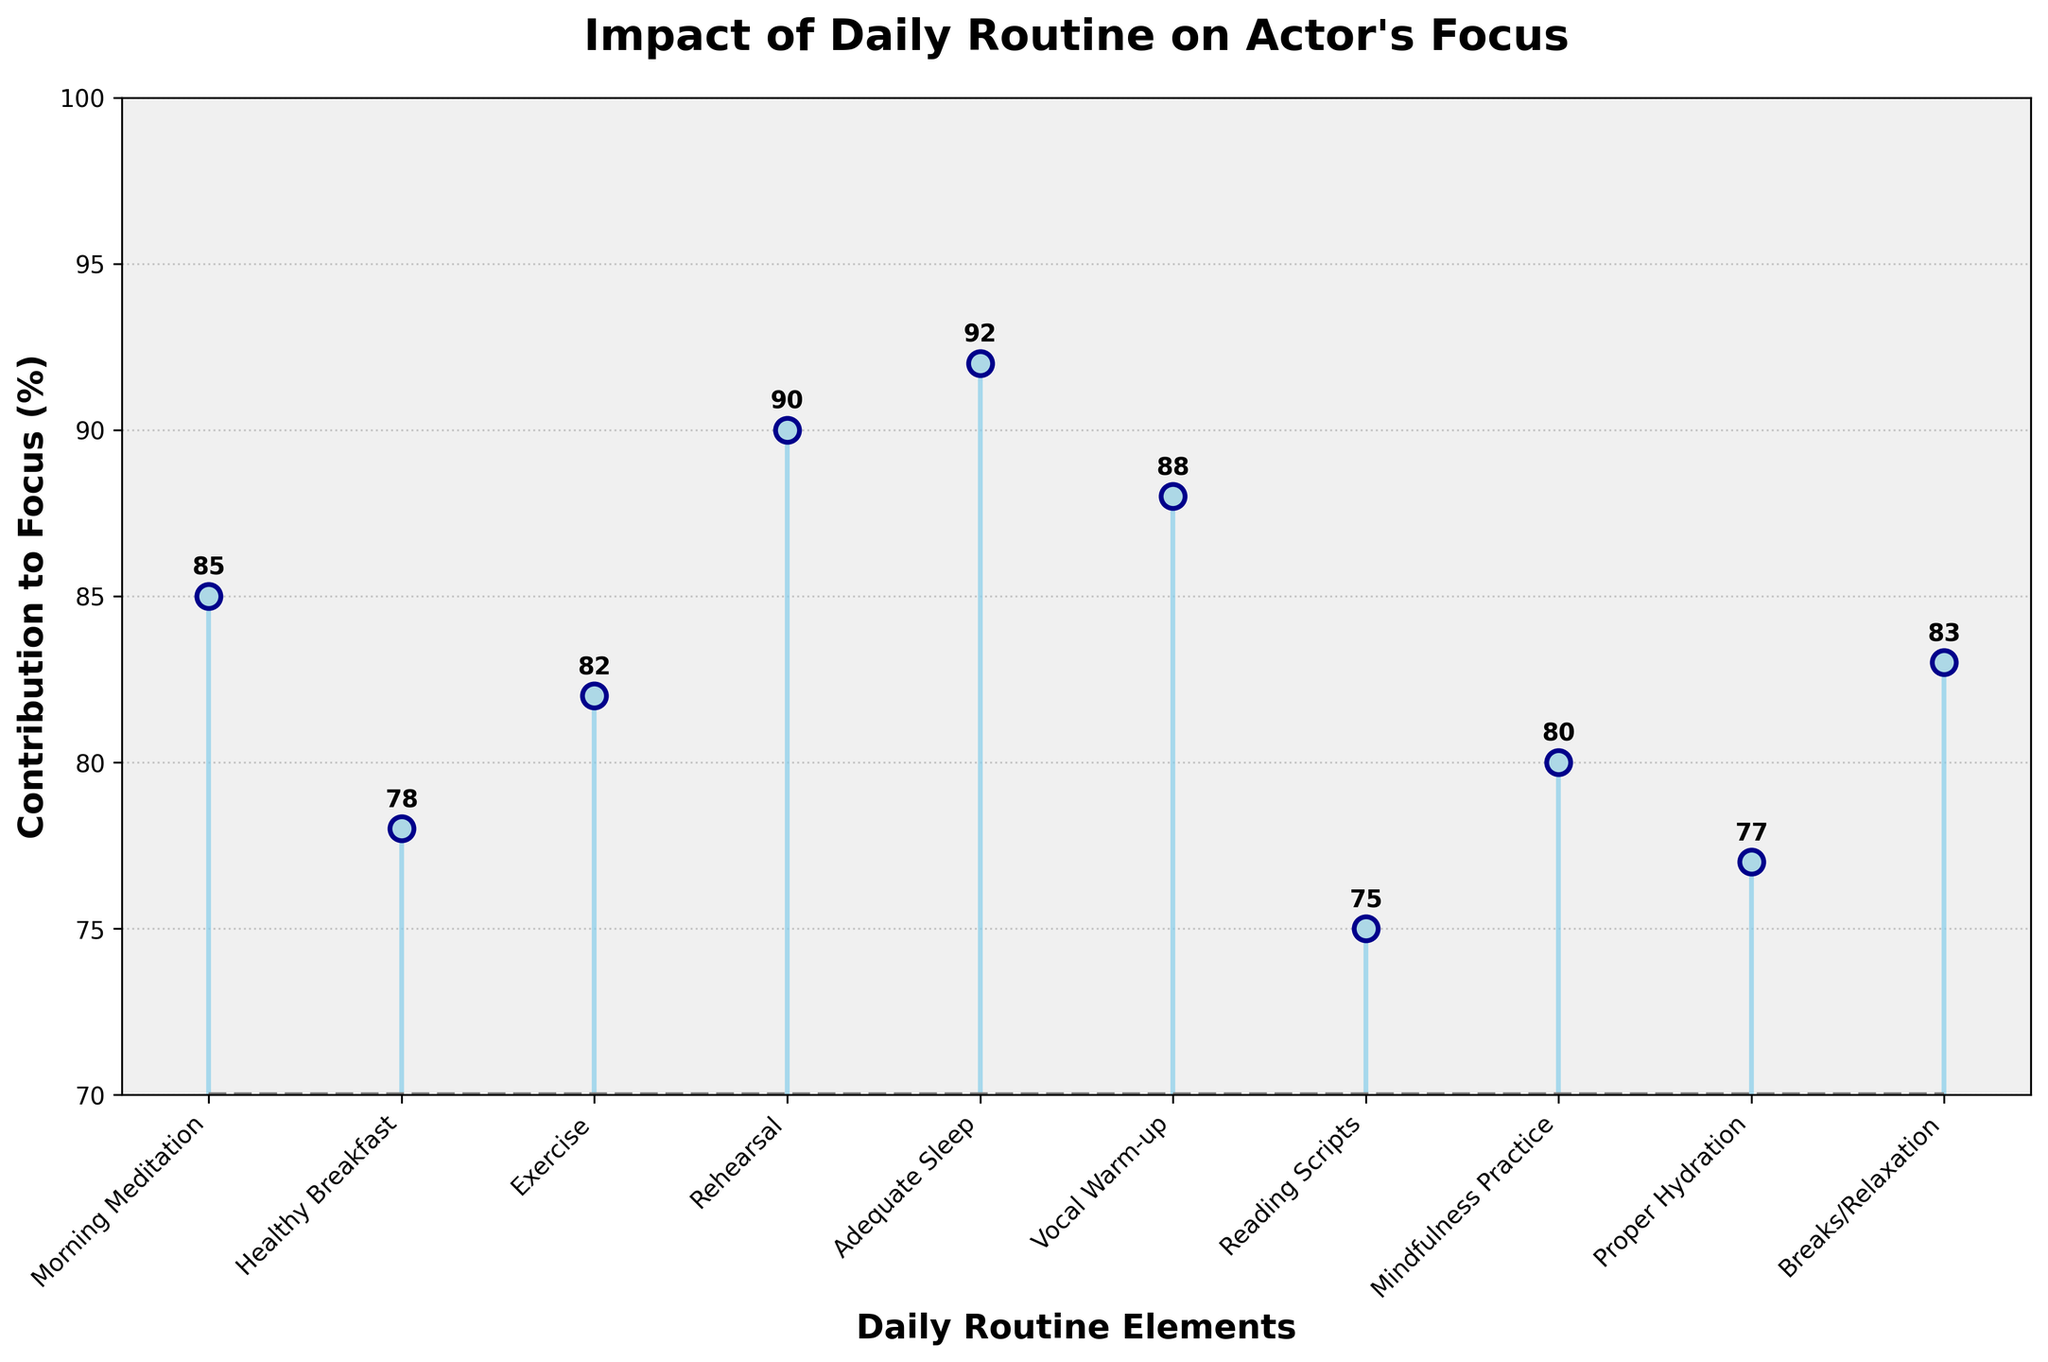How many data points are shown in the figure? Count each labeled item on the x-axis that corresponds to a daily routine element. There are 10 data points labeled on the x-axis.
Answer: 10 Which daily routine element contributes the most to an actor's focus? By looking at the highest point on the y-axis, 'Adequate Sleep' has the value of 92%, which is the highest.
Answer: Adequate Sleep What is the contribution percentage for the Vocal Warm-up routine? Locate the 'Vocal Warm-up' label on the x-axis and read the corresponding value from the y-axis, which is labeled as 88%.
Answer: 88% What is the range of contribution percentages among the daily routine elements? The lowest contribution is for 'Reading Scripts' at 75% and the highest is for 'Adequate Sleep' at 92%. The range is calculated as 92% - 75% = 17%.
Answer: 17% Which routine element has a lower contribution to focus: Mindfulness Practice or Proper Hydration? Compare the heights of the markers for 'Mindfulness Practice' and 'Proper Hydration'. 'Proper Hydration' has a contribution of 77%, whereas 'Mindfulness Practice' has 80%. Hence, 'Proper Hydration' is lower.
Answer: Proper Hydration What is the mean contribution percentage of all daily routine elements? Sum all the percentages and divide by the number of elements: (85 + 78 + 82 + 90 + 92 + 88 + 75 + 80 + 77 + 83) / 10 = 82
Answer: 82% Which daily routine element contributes more to focus, Exercise or Breaks/Relaxation? Compare the heights of the markers for 'Exercise' and 'Breaks/Relaxation'. 'Exercise' has 82% and 'Breaks/Relaxation' has 83%. Therefore, 'Breaks/Relaxation' contributes more.
Answer: Breaks/Relaxation What is the second highest contributing daily routine element? Identify the data point with the second highest y-axis value. 'Rehearsal' has the second highest contribution at 90%.
Answer: Rehearsal What is the difference in contribution percentages between the highest and lowest routine elements? Subtract the lowest contribution value ('Reading Scripts' at 75%) from the highest ('Adequate Sleep' at 92%): 92% - 75% = 17%.
Answer: 17% Which daily routine element has a higher contribution to focus, Morning Meditation or Healthy Breakfast? Compare the heights of the markers for 'Morning Meditation' and 'Healthy Breakfast'. 'Morning Meditation' has 85% while 'Healthy Breakfast' is at 78%, so 'Morning Meditation' is higher.
Answer: Morning Meditation 